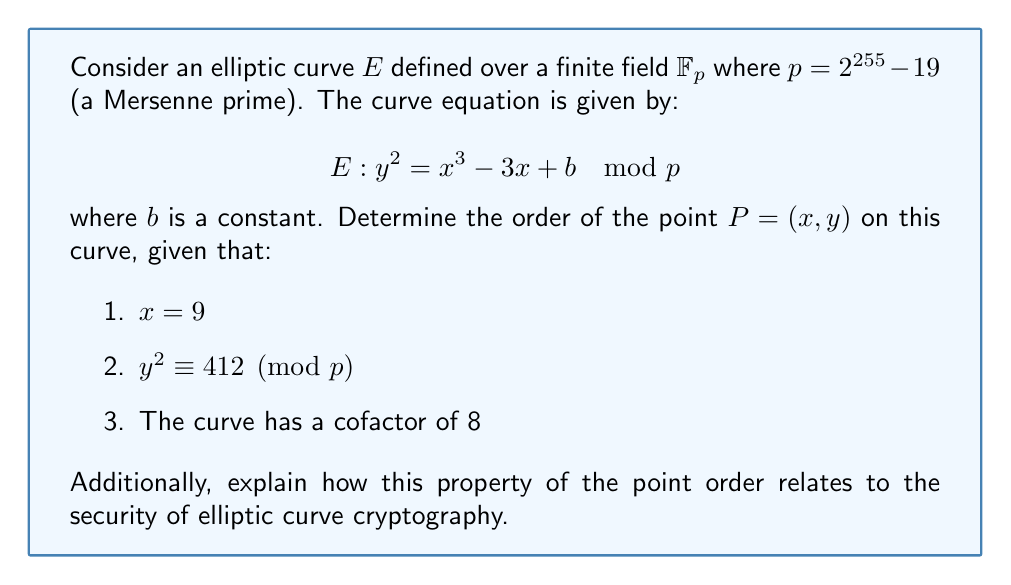Teach me how to tackle this problem. To solve this problem, we'll follow these steps:

1) First, we need to understand that the order of a point $P$ on an elliptic curve is the smallest positive integer $n$ such that $nP = O$ (the point at infinity).

2) In elliptic curve cryptography over finite fields, the number of points on the curve (including the point at infinity) is denoted as $\#E(\mathbb{F}_p)$. This is also known as the curve order.

3) The curve order is related to the field size by Hasse's theorem:

   $$p + 1 - 2\sqrt{p} \leq \#E(\mathbb{F}_p) \leq p + 1 + 2\sqrt{p}$$

4) Given that the curve has a cofactor of 8, we know that:

   $$\#E(\mathbb{F}_p) = 8 \cdot n$$

   where $n$ is a prime number. This $n$ is the order of the subgroup generated by the base point used in the cryptographic operations.

5) The order of any point on the curve must divide the curve order. Therefore, the order of $P$ must be either 1, 2, 4, 8, or $n$.

6) To determine which of these is the actual order, we need to compute multiples of $P$ until we reach the point at infinity or exhaust all possibilities.

7) However, as experienced cryptographers, we know that for secure elliptic curve cryptography, we typically work with points of large prime order. The cofactor of 8 suggests that the order of $P$ is likely to be $n$.

8) To confirm this, we would normally need to compute $nP$ and verify that it equals the point at infinity. However, computing $n$ exactly would be computationally intensive for such a large prime field.

9) In practice, for curves used in cryptography, points are typically chosen to have the maximum possible order (except for a small cofactor). This ensures the hardness of the discrete logarithm problem on which the security of elliptic curve cryptography relies.

10) The security of elliptic curve cryptography depends on the difficulty of the elliptic curve discrete logarithm problem (ECDLP). The hardness of this problem is directly related to the order of the point used as the base point for cryptographic operations. A larger order means a harder problem, providing better security.

11) In this case, with a prime field of size $p = 2^{255} - 19$ and a cofactor of 8, the order of the subgroup generated by $P$ (assuming it's a generator) would be approximately $2^{252}$, which is considered sufficiently large for current cryptographic standards.
Answer: The order of point $P$ is most likely $n$, where $n$ is a prime number such that $8n = \#E(\mathbb{F}_p)$. This $n$ is approximately $2^{252}$. The large prime order of this point contributes to the security of elliptic curve cryptography by ensuring the hardness of the elliptic curve discrete logarithm problem. 